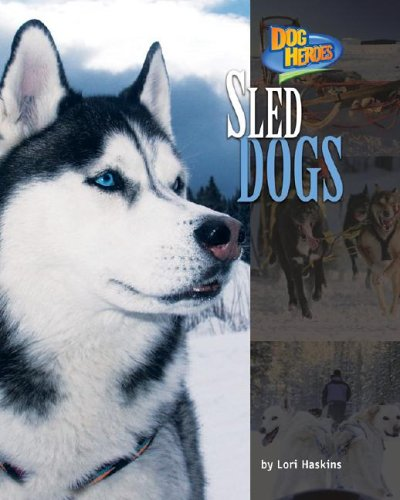What type of book is this? This is a children's educational book that falls into the 'Animal & Pet Care' and 'Sports & Outdoors' categories, focusing on the lives and adventures of sled dogs. 